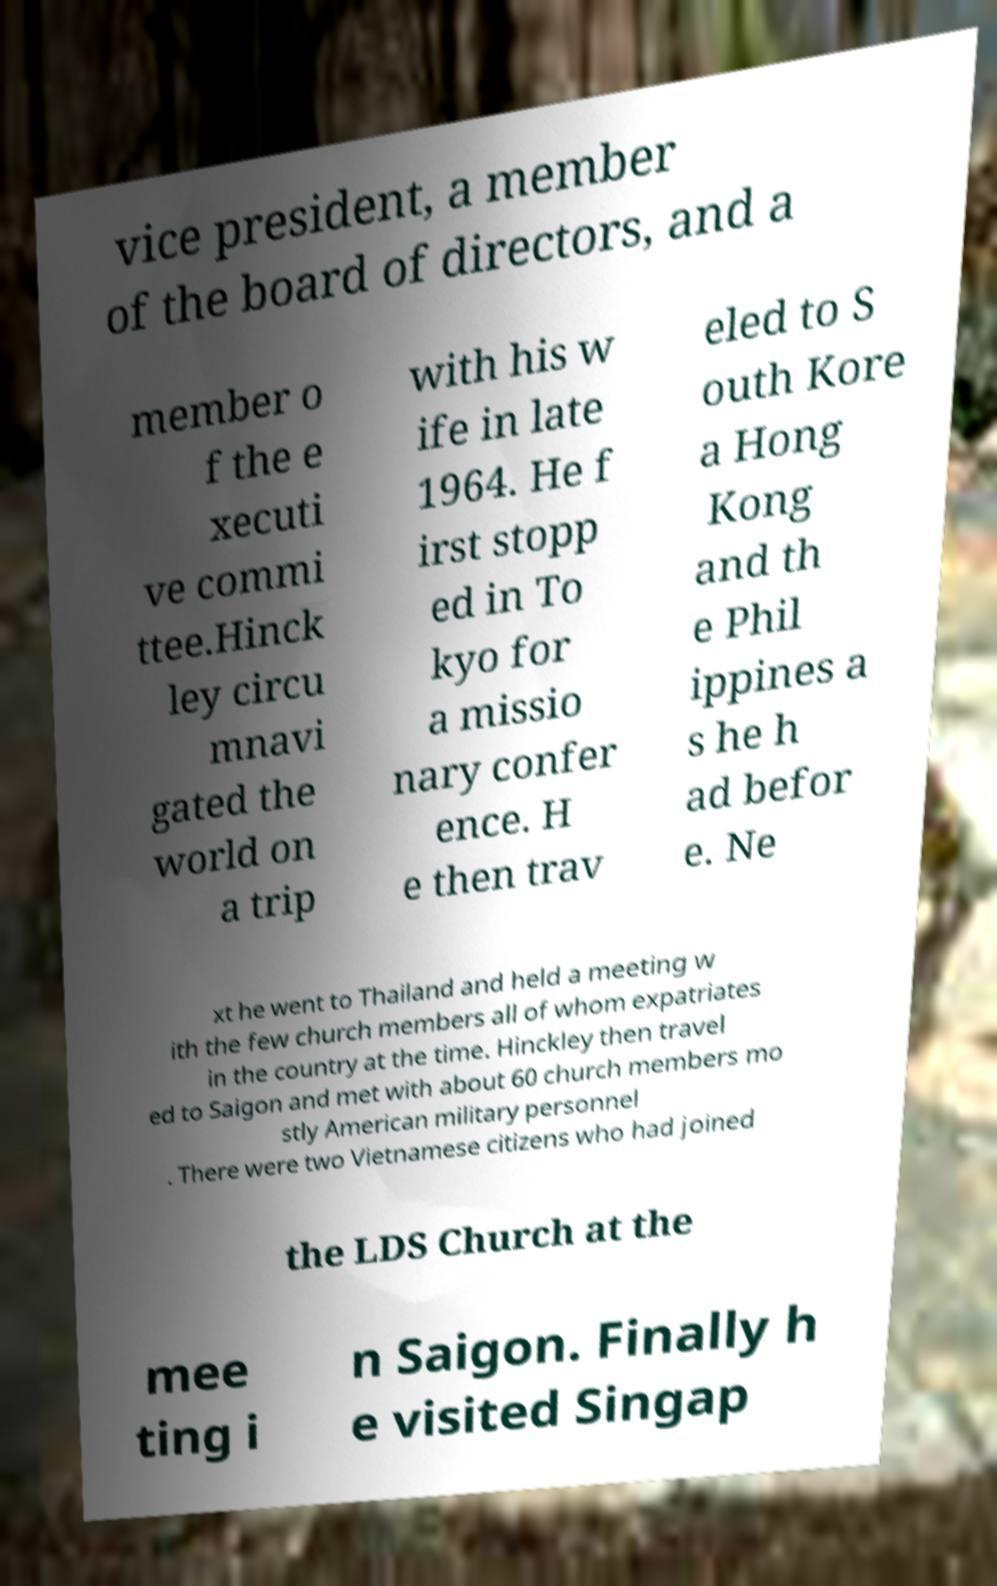Could you extract and type out the text from this image? vice president, a member of the board of directors, and a member o f the e xecuti ve commi ttee.Hinck ley circu mnavi gated the world on a trip with his w ife in late 1964. He f irst stopp ed in To kyo for a missio nary confer ence. H e then trav eled to S outh Kore a Hong Kong and th e Phil ippines a s he h ad befor e. Ne xt he went to Thailand and held a meeting w ith the few church members all of whom expatriates in the country at the time. Hinckley then travel ed to Saigon and met with about 60 church members mo stly American military personnel . There were two Vietnamese citizens who had joined the LDS Church at the mee ting i n Saigon. Finally h e visited Singap 